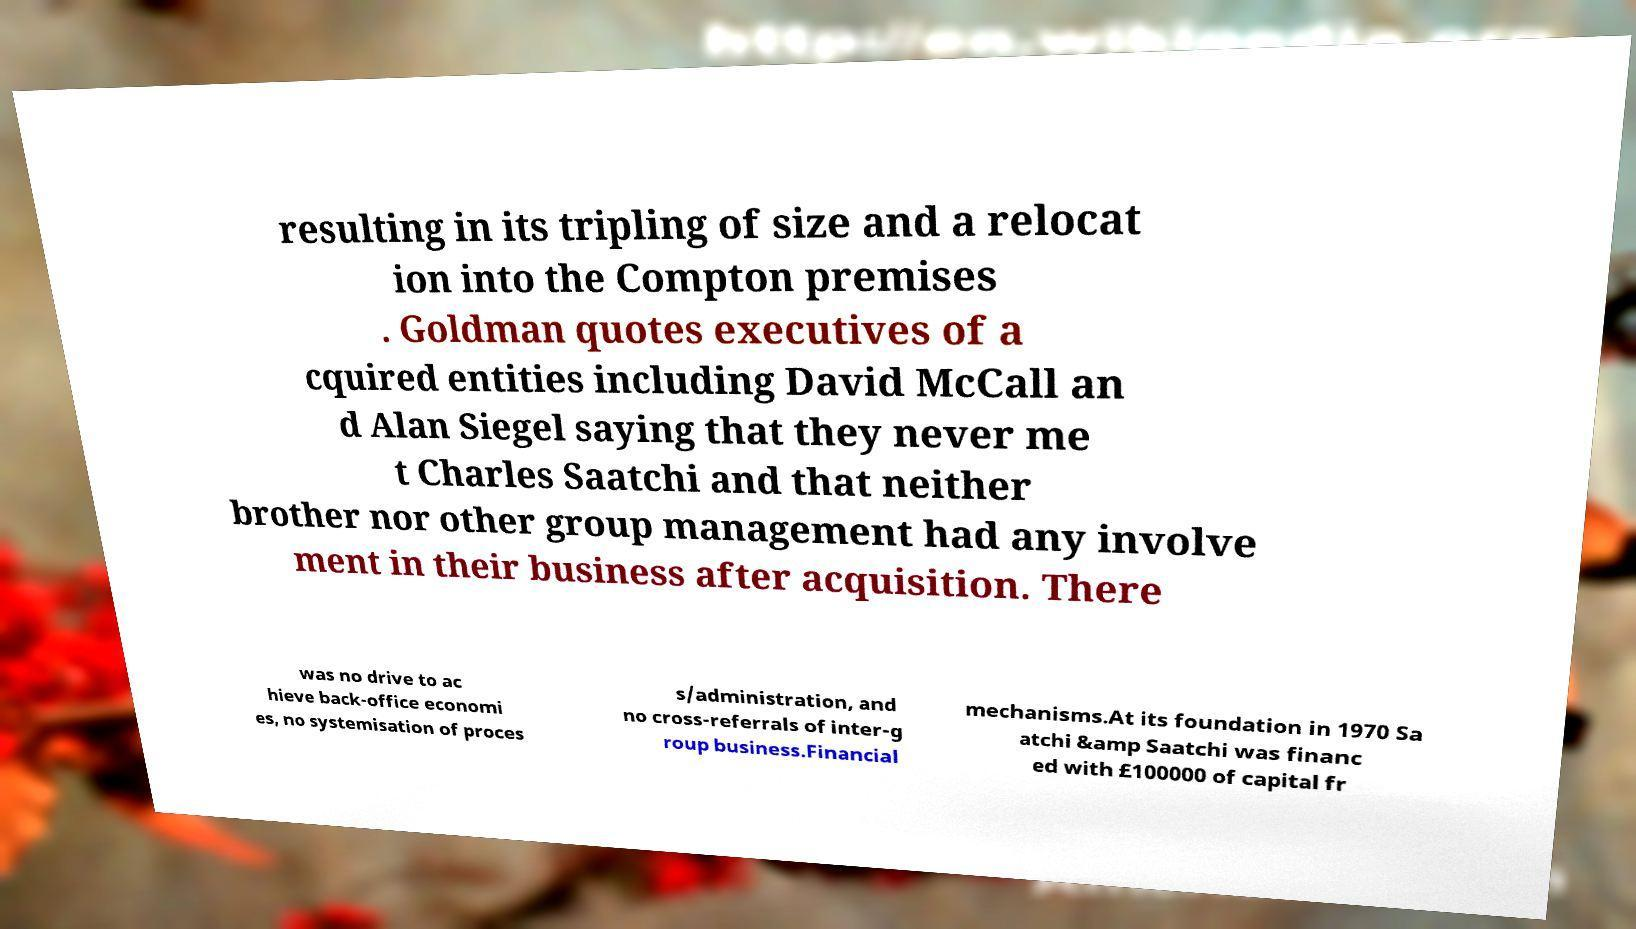Could you extract and type out the text from this image? resulting in its tripling of size and a relocat ion into the Compton premises . Goldman quotes executives of a cquired entities including David McCall an d Alan Siegel saying that they never me t Charles Saatchi and that neither brother nor other group management had any involve ment in their business after acquisition. There was no drive to ac hieve back-office economi es, no systemisation of proces s/administration, and no cross-referrals of inter-g roup business.Financial mechanisms.At its foundation in 1970 Sa atchi &amp Saatchi was financ ed with £100000 of capital fr 